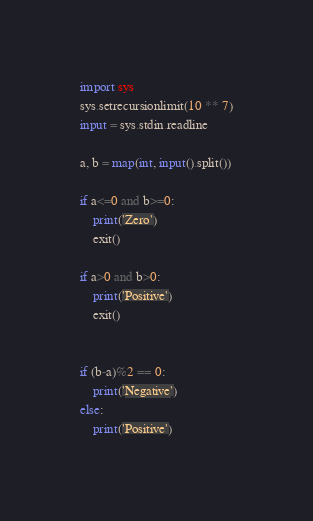Convert code to text. <code><loc_0><loc_0><loc_500><loc_500><_Python_>import sys
sys.setrecursionlimit(10 ** 7)
input = sys.stdin.readline

a, b = map(int, input().split())

if a<=0 and b>=0:
    print('Zero')
    exit()

if a>0 and b>0:
    print('Positive')
    exit()


if (b-a)%2 == 0:
    print('Negative')
else:
    print('Positive')</code> 